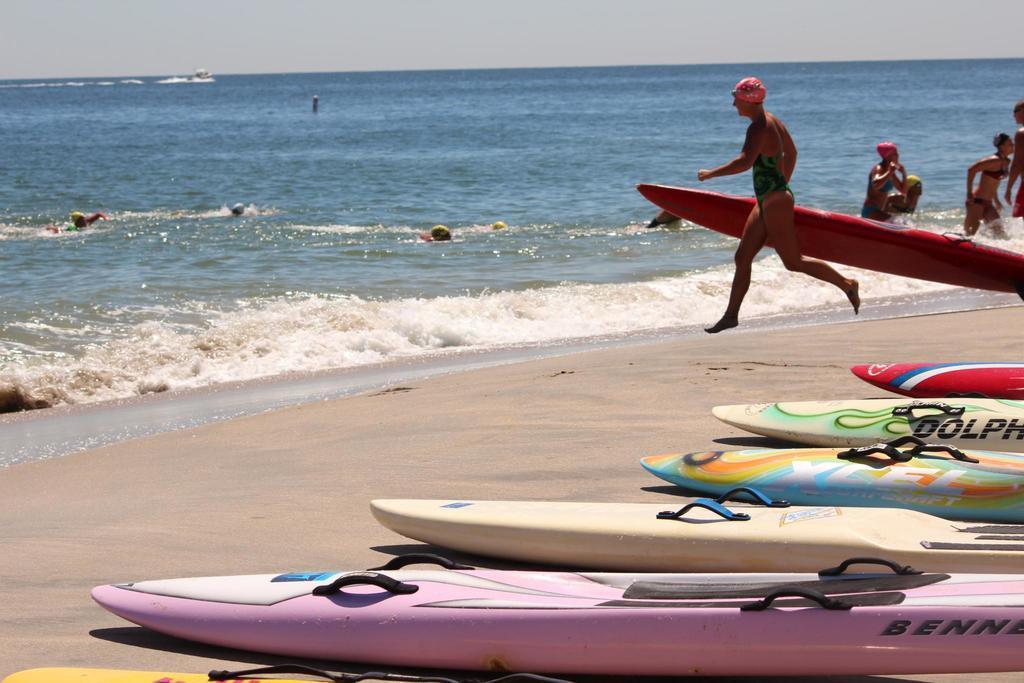<image>
Create a compact narrative representing the image presented. A pink board laying on the sand has BENNE on the side. 